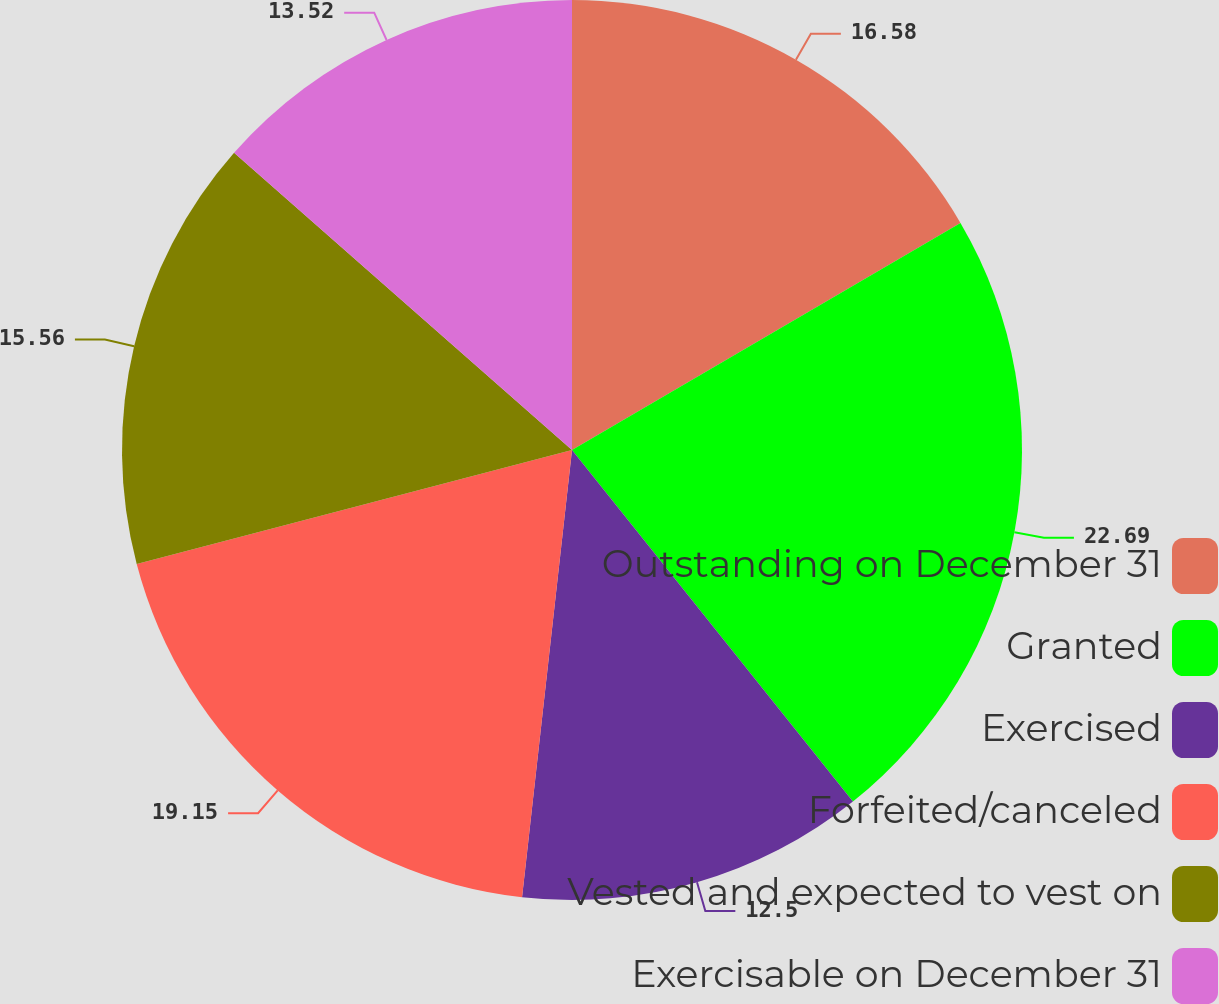Convert chart. <chart><loc_0><loc_0><loc_500><loc_500><pie_chart><fcel>Outstanding on December 31<fcel>Granted<fcel>Exercised<fcel>Forfeited/canceled<fcel>Vested and expected to vest on<fcel>Exercisable on December 31<nl><fcel>16.58%<fcel>22.69%<fcel>12.5%<fcel>19.15%<fcel>15.56%<fcel>13.52%<nl></chart> 